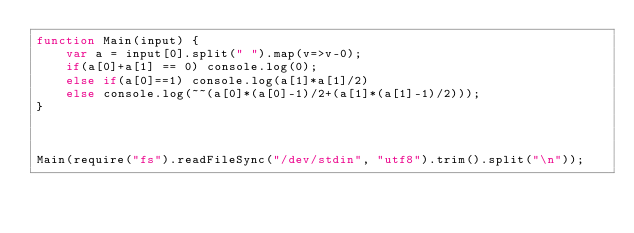Convert code to text. <code><loc_0><loc_0><loc_500><loc_500><_JavaScript_>function Main(input) {
    var a = input[0].split(" ").map(v=>v-0);
    if(a[0]+a[1] == 0) console.log(0);
    else if(a[0]==1) console.log(a[1]*a[1]/2)
    else console.log(~~(a[0]*(a[0]-1)/2+(a[1]*(a[1]-1)/2)));
}



Main(require("fs").readFileSync("/dev/stdin", "utf8").trim().split("\n"));</code> 